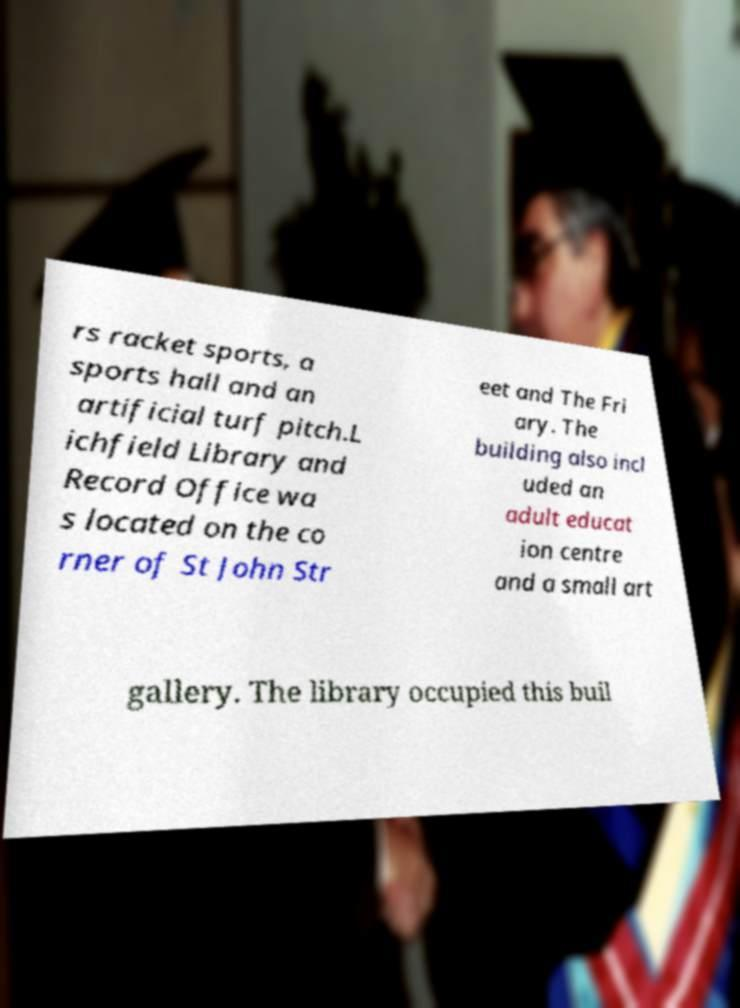What messages or text are displayed in this image? I need them in a readable, typed format. rs racket sports, a sports hall and an artificial turf pitch.L ichfield Library and Record Office wa s located on the co rner of St John Str eet and The Fri ary. The building also incl uded an adult educat ion centre and a small art gallery. The library occupied this buil 